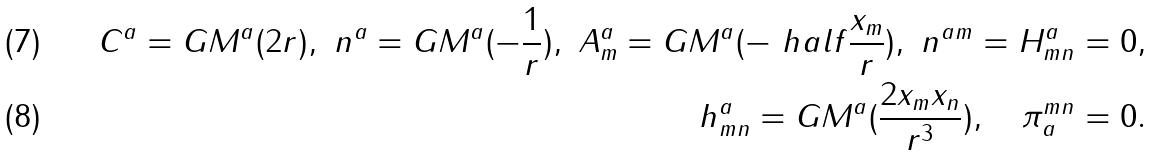Convert formula to latex. <formula><loc_0><loc_0><loc_500><loc_500>C ^ { a } = G M ^ { a } ( 2 r ) , \ n ^ { a } = G M ^ { a } ( - \frac { 1 } { r } ) , \ A ^ { a } _ { m } = G M ^ { a } ( - \ h a l f \frac { x _ { m } } { r } ) , \ n ^ { a m } = H ^ { a } _ { m n } = 0 , \\ h ^ { a } _ { m n } = G M ^ { a } ( \frac { 2 x _ { m } x _ { n } } { r ^ { 3 } } ) , \quad \pi _ { a } ^ { m n } = 0 .</formula> 